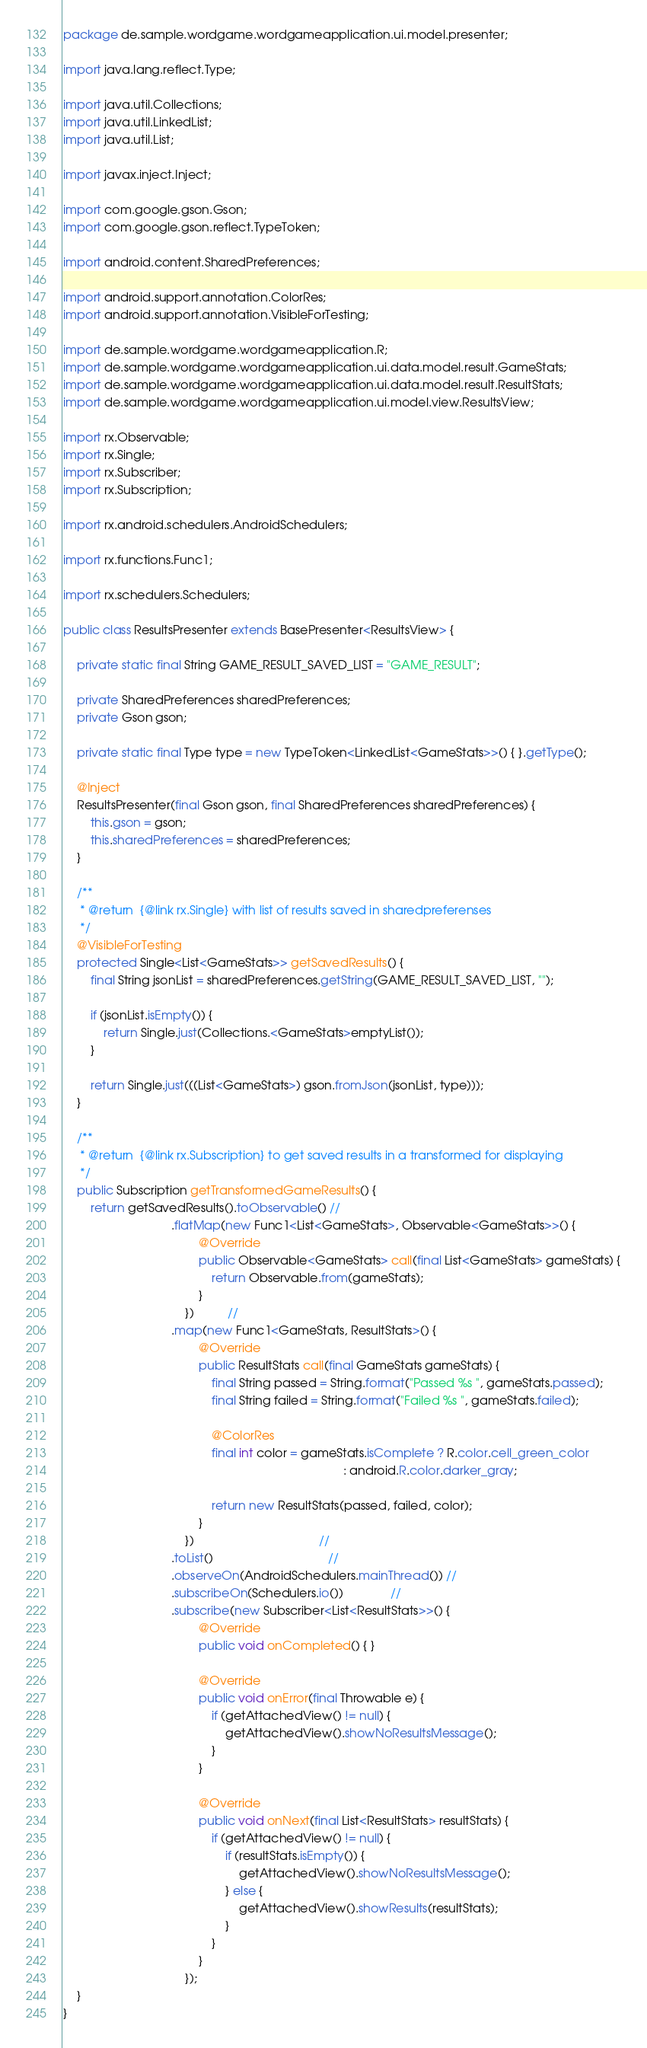Convert code to text. <code><loc_0><loc_0><loc_500><loc_500><_Java_>package de.sample.wordgame.wordgameapplication.ui.model.presenter;

import java.lang.reflect.Type;

import java.util.Collections;
import java.util.LinkedList;
import java.util.List;

import javax.inject.Inject;

import com.google.gson.Gson;
import com.google.gson.reflect.TypeToken;

import android.content.SharedPreferences;

import android.support.annotation.ColorRes;
import android.support.annotation.VisibleForTesting;

import de.sample.wordgame.wordgameapplication.R;
import de.sample.wordgame.wordgameapplication.ui.data.model.result.GameStats;
import de.sample.wordgame.wordgameapplication.ui.data.model.result.ResultStats;
import de.sample.wordgame.wordgameapplication.ui.model.view.ResultsView;

import rx.Observable;
import rx.Single;
import rx.Subscriber;
import rx.Subscription;

import rx.android.schedulers.AndroidSchedulers;

import rx.functions.Func1;

import rx.schedulers.Schedulers;

public class ResultsPresenter extends BasePresenter<ResultsView> {

    private static final String GAME_RESULT_SAVED_LIST = "GAME_RESULT";

    private SharedPreferences sharedPreferences;
    private Gson gson;

    private static final Type type = new TypeToken<LinkedList<GameStats>>() { }.getType();

    @Inject
    ResultsPresenter(final Gson gson, final SharedPreferences sharedPreferences) {
        this.gson = gson;
        this.sharedPreferences = sharedPreferences;
    }

    /**
     * @return  {@link rx.Single} with list of results saved in sharedpreferenses
     */
    @VisibleForTesting
    protected Single<List<GameStats>> getSavedResults() {
        final String jsonList = sharedPreferences.getString(GAME_RESULT_SAVED_LIST, "");

        if (jsonList.isEmpty()) {
            return Single.just(Collections.<GameStats>emptyList());
        }

        return Single.just(((List<GameStats>) gson.fromJson(jsonList, type)));
    }

    /**
     * @return  {@link rx.Subscription} to get saved results in a transformed for displaying
     */
    public Subscription getTransformedGameResults() {
        return getSavedResults().toObservable() //
                                .flatMap(new Func1<List<GameStats>, Observable<GameStats>>() {
                                        @Override
                                        public Observable<GameStats> call(final List<GameStats> gameStats) {
                                            return Observable.from(gameStats);
                                        }
                                    })          //
                                .map(new Func1<GameStats, ResultStats>() {
                                        @Override
                                        public ResultStats call(final GameStats gameStats) {
                                            final String passed = String.format("Passed %s ", gameStats.passed);
                                            final String failed = String.format("Failed %s ", gameStats.failed);

                                            @ColorRes
                                            final int color = gameStats.isComplete ? R.color.cell_green_color
                                                                                   : android.R.color.darker_gray;

                                            return new ResultStats(passed, failed, color);
                                        }
                                    })                                     //
                                .toList()                                  //
                                .observeOn(AndroidSchedulers.mainThread()) //
                                .subscribeOn(Schedulers.io())              //
                                .subscribe(new Subscriber<List<ResultStats>>() {
                                        @Override
                                        public void onCompleted() { }

                                        @Override
                                        public void onError(final Throwable e) {
                                            if (getAttachedView() != null) {
                                                getAttachedView().showNoResultsMessage();
                                            }
                                        }

                                        @Override
                                        public void onNext(final List<ResultStats> resultStats) {
                                            if (getAttachedView() != null) {
                                                if (resultStats.isEmpty()) {
                                                    getAttachedView().showNoResultsMessage();
                                                } else {
                                                    getAttachedView().showResults(resultStats);
                                                }
                                            }
                                        }
                                    });
    }
}
</code> 